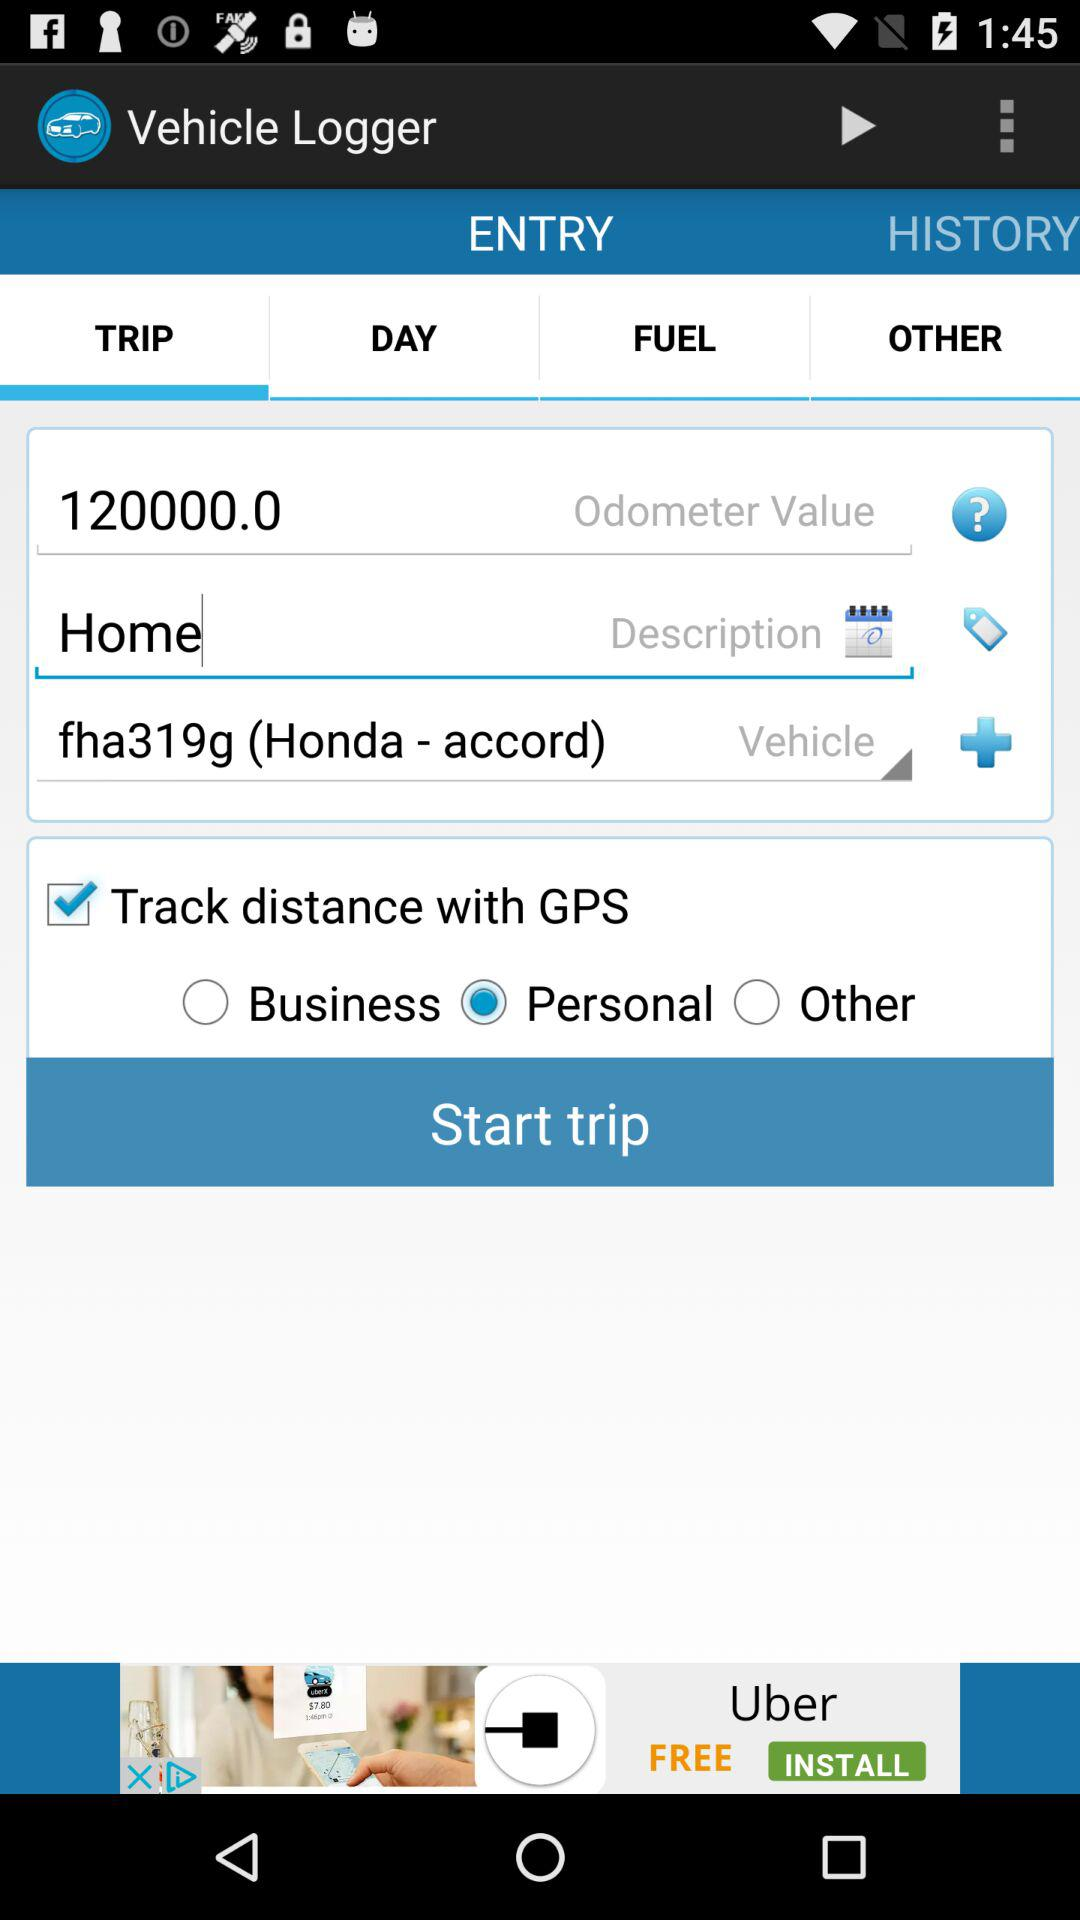What's the vehicle name? The vehicle name is "accord". 